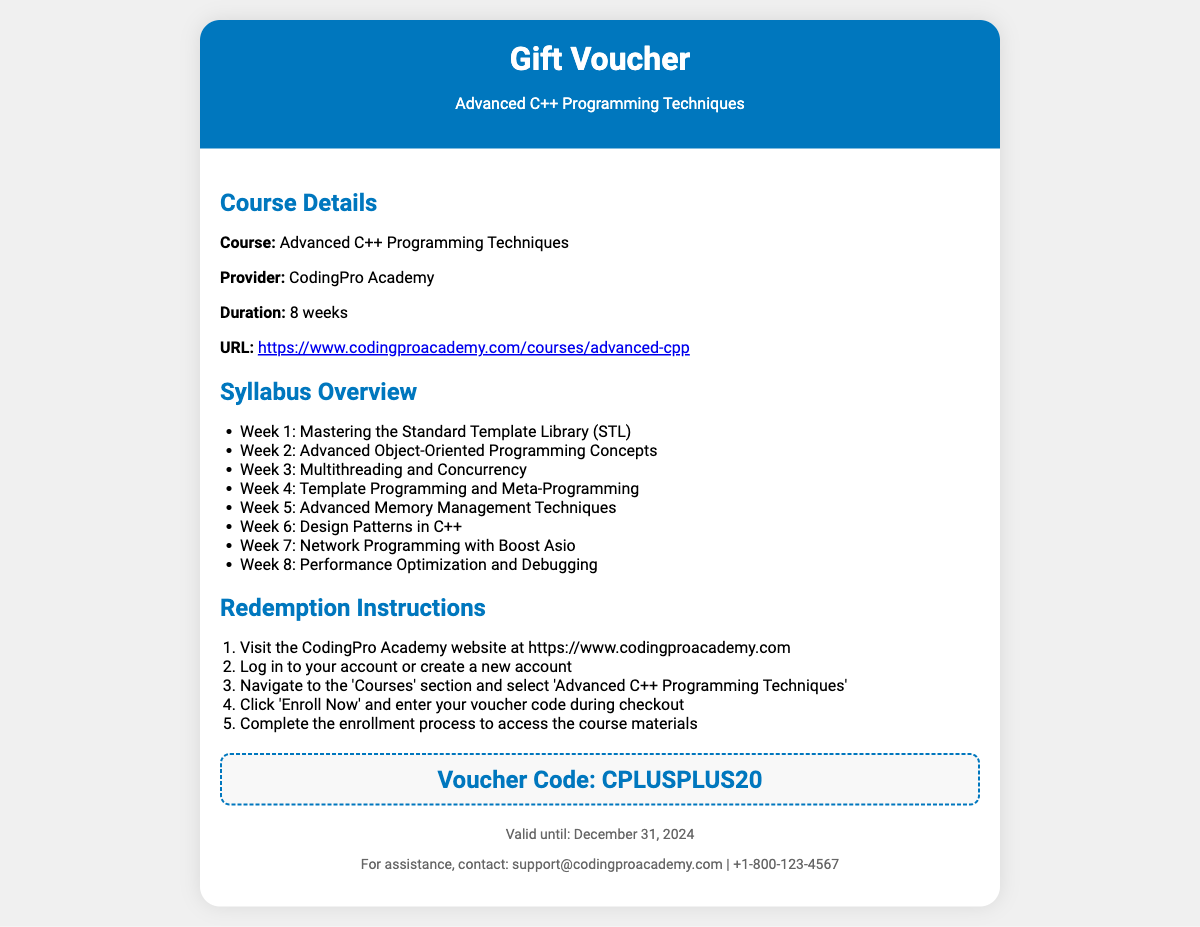What is the course duration? The course duration, as mentioned, is 8 weeks.
Answer: 8 weeks Who is the course provider? The document states that the provider of the course is CodingPro Academy.
Answer: CodingPro Academy What is the voucher code? The code needed for the voucher redemption is provided in the document.
Answer: CPLUSPLUS20 Until when is the voucher valid? The expiration date of the voucher is clearly stated in the document.
Answer: December 31, 2024 What is the main topic of the course? The document specifies that the course is about Advanced C++ Programming Techniques.
Answer: Advanced C++ Programming Techniques How many weeks are included in the syllabus? The syllabus has 8 weeks of topics listed, totaling to 8 weeks.
Answer: 8 What should you do first to redeem the voucher? The first step in the redemption process is clearly mentioned in the document.
Answer: Visit the CodingPro Academy website Which week covers Network Programming? The syllabus outlines that week 7 focuses on a specific topic.
Answer: Week 7 What should you do after entering the voucher code? The document instructs what to do after entering the code during checkout.
Answer: Complete the enrollment process 